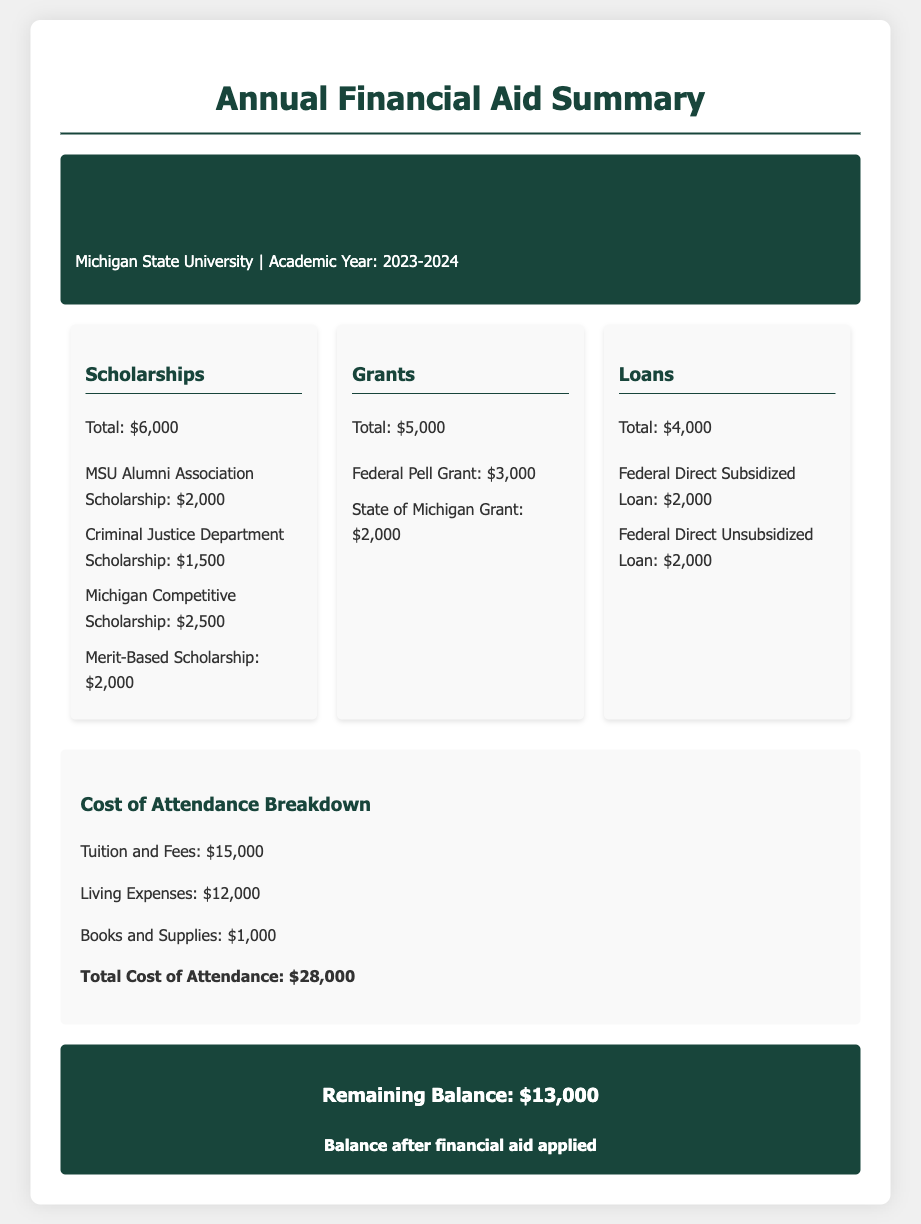What is the total amount for scholarships? The total amount for scholarships is listed in the aid summary section of the document.
Answer: $6,000 How much is the Federal Pell Grant? The amount for the Federal Pell Grant is detailed under the Grants section of the document.
Answer: $3,000 What is the total cost of attendance? The total cost of attendance is provided in the cost breakdown section, summing up tuition, living expenses, and books.
Answer: $28,000 What is the remaining balance after financial aid? The remaining balance is stated in the summary section after all financial aid has been applied.
Answer: $13,000 What scholarship is offered by the Criminal Justice Department? The document specifies the scholarships and their amounts, including the one from the Criminal Justice Department.
Answer: $1,500 How much are the Federal Direct Subsidized and Unsubsidized Loans combined? This requires adding both loan amounts listed in the Loans section of the document.
Answer: $4,000 What is the amount for the State of Michigan Grant? The amount for the State of Michigan Grant is provided in the Grants section of the aid summary.
Answer: $2,000 What are the total living expenses? The total living expenses are detailed in the cost breakdown section of the document.
Answer: $12,000 What is the total for the Merit-Based Scholarship? The document lists the specific scholarships along with their amounts and identifies the Merit-Based Scholarship.
Answer: $2,000 